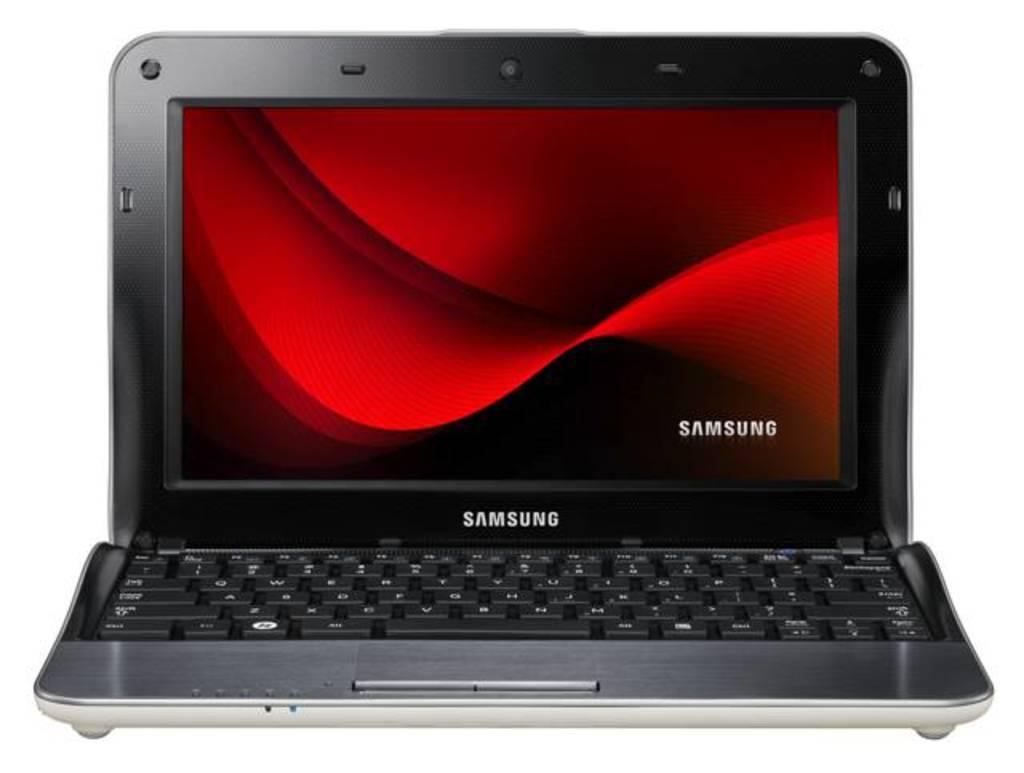What electronic device is present in the image? There is a laptop in the image. What features are present on the laptop? The laptop has a keyboard, buttons, and a screen. What can be seen on the screen of the laptop? There is text visible on the screen. What type of chess pieces are visible on the laptop screen? There are no chess pieces visible on the laptop screen; only text is present. How does the growth of the sea affect the laptop in the image? There is no reference to the sea or any growth in the image, so it cannot be determined how they might affect the laptop. 